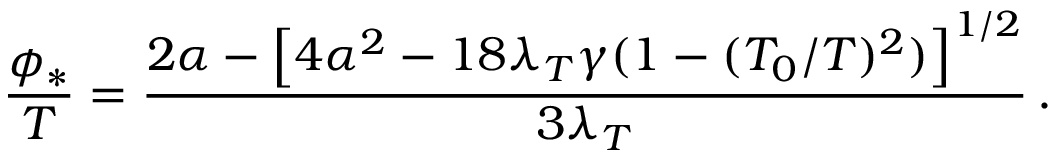Convert formula to latex. <formula><loc_0><loc_0><loc_500><loc_500>\frac { \phi _ { * } } { T } = \frac { 2 \alpha - \left [ 4 \alpha ^ { 2 } - 1 8 \lambda _ { T } \gamma ( 1 - ( T _ { 0 } / T ) ^ { 2 } ) \right ] ^ { 1 / 2 } } { 3 \lambda _ { T } } \, .</formula> 